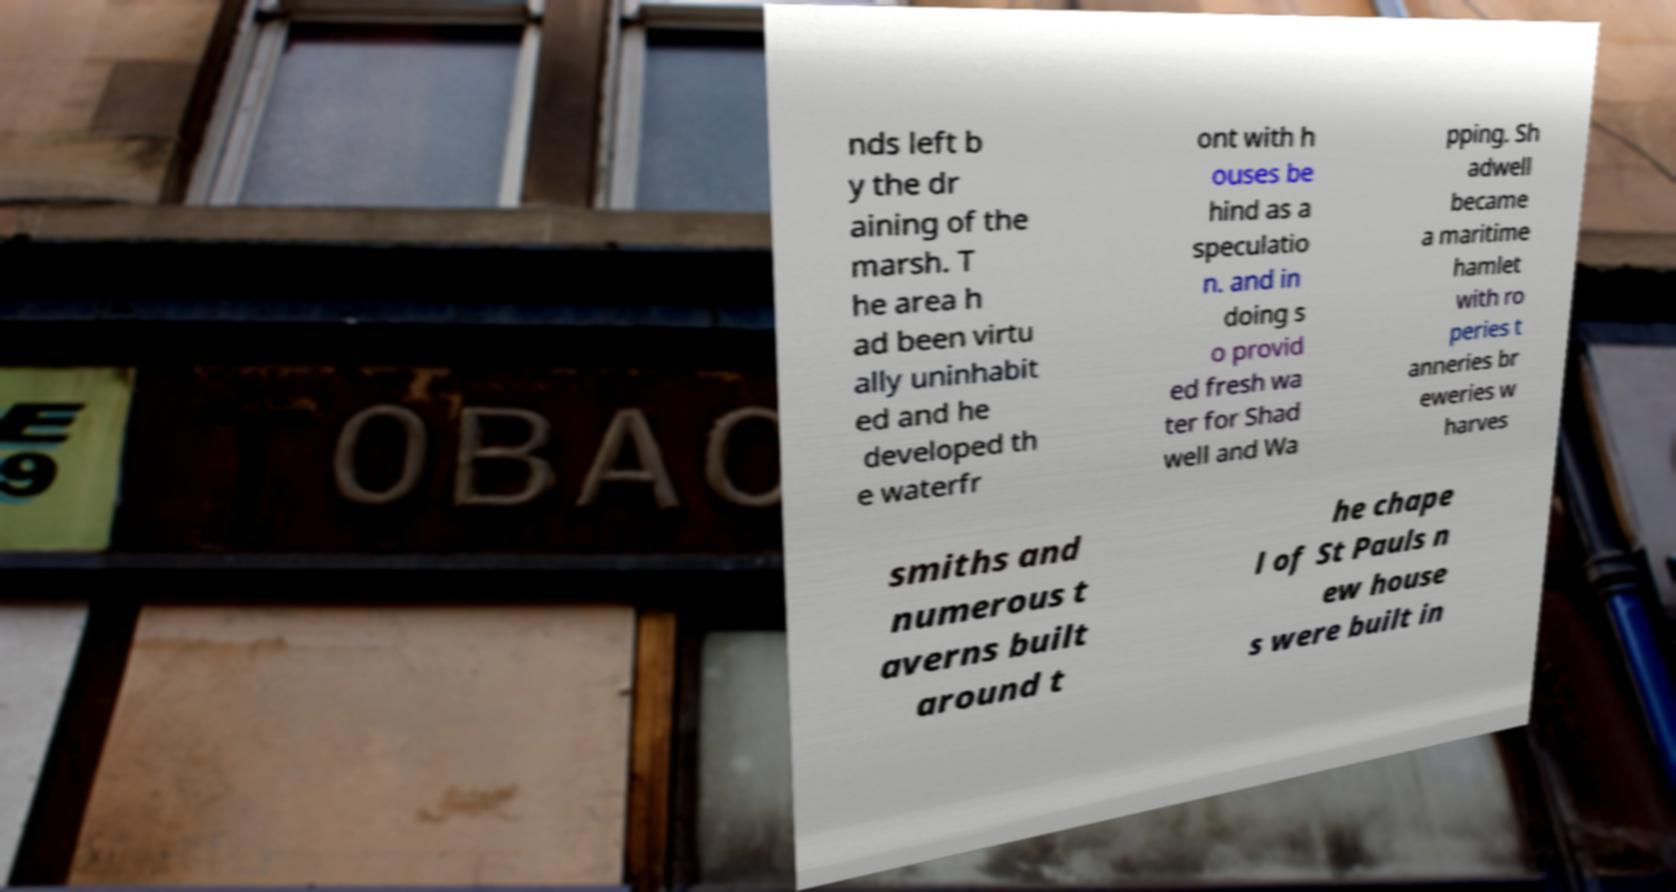Can you read and provide the text displayed in the image?This photo seems to have some interesting text. Can you extract and type it out for me? nds left b y the dr aining of the marsh. T he area h ad been virtu ally uninhabit ed and he developed th e waterfr ont with h ouses be hind as a speculatio n. and in doing s o provid ed fresh wa ter for Shad well and Wa pping. Sh adwell became a maritime hamlet with ro peries t anneries br eweries w harves smiths and numerous t averns built around t he chape l of St Pauls n ew house s were built in 